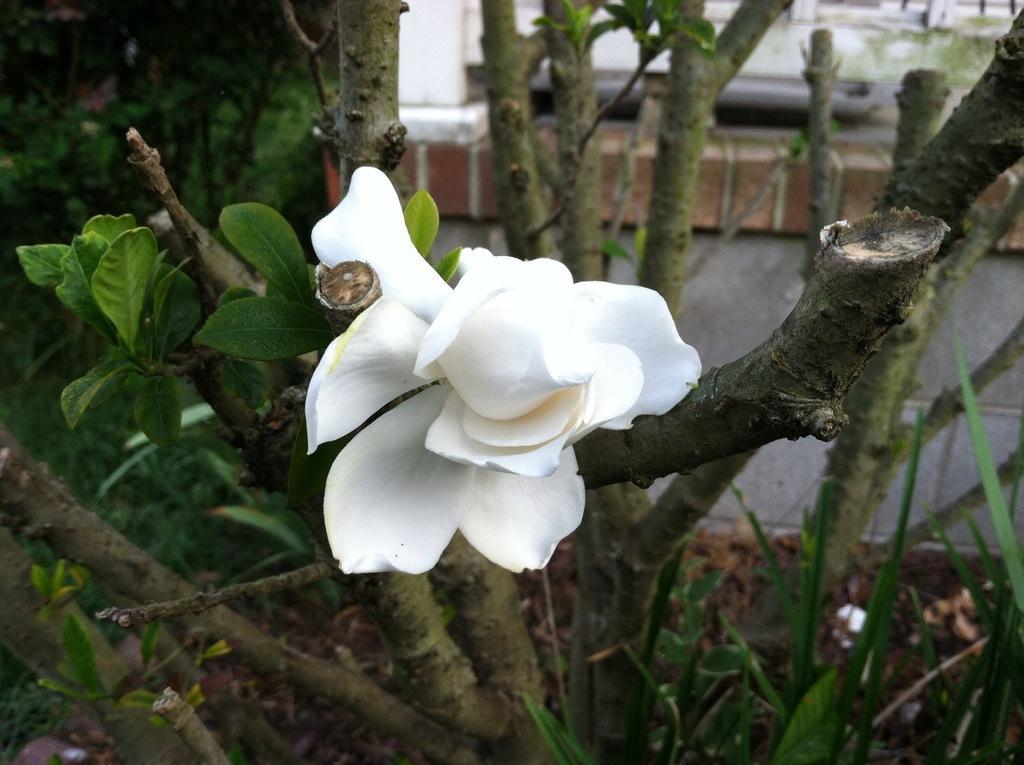Please provide a concise description of this image. As we can see in the image are plants, tree stems and a white color flower. 